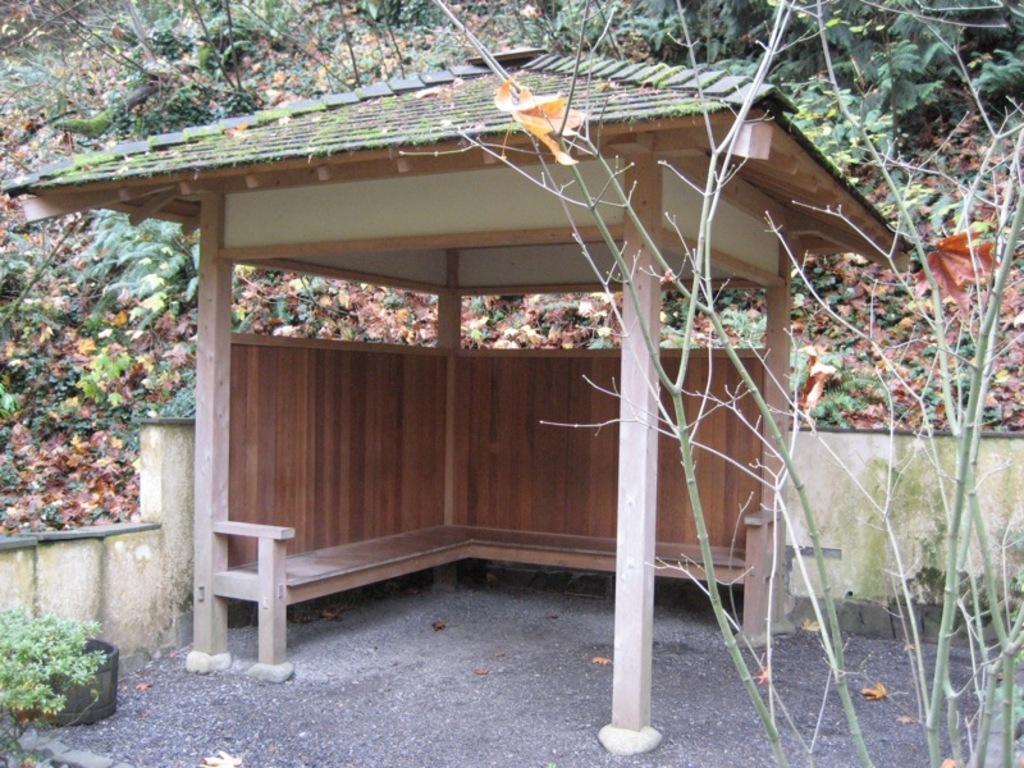Can you describe this image briefly? In this image in the center there is a shelter. In the background there are trees and there are dry leaves. In the front on the left side there are leaves. On the right side there is dry plant. 